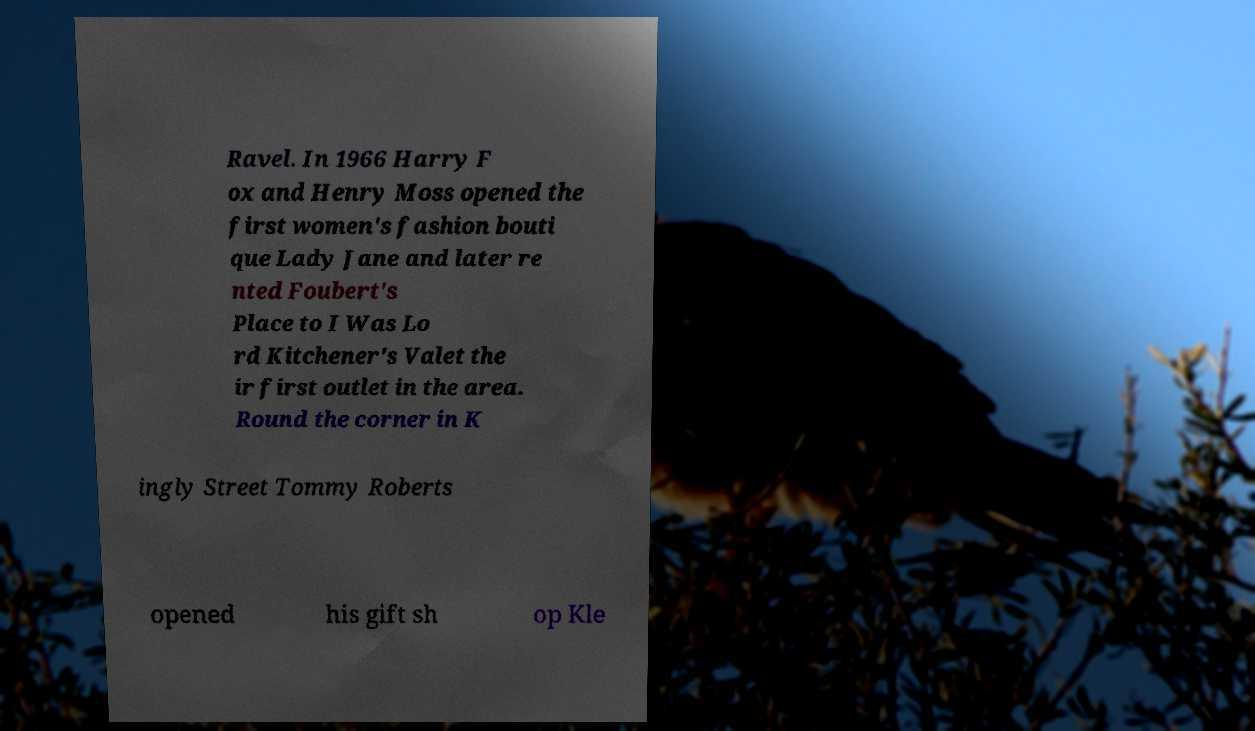There's text embedded in this image that I need extracted. Can you transcribe it verbatim? Ravel. In 1966 Harry F ox and Henry Moss opened the first women's fashion bouti que Lady Jane and later re nted Foubert's Place to I Was Lo rd Kitchener's Valet the ir first outlet in the area. Round the corner in K ingly Street Tommy Roberts opened his gift sh op Kle 